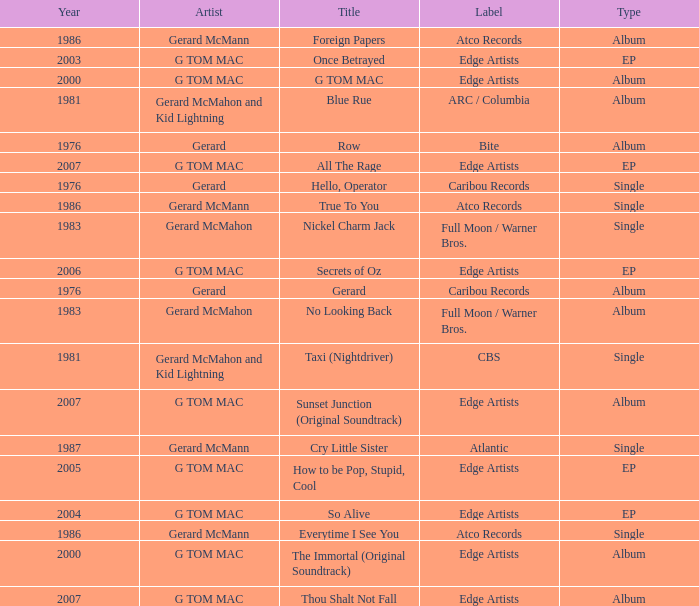Which type has a title of so alive? EP. 